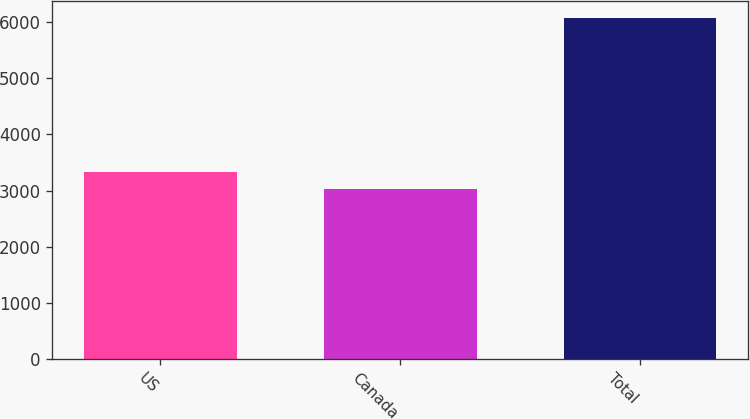Convert chart. <chart><loc_0><loc_0><loc_500><loc_500><bar_chart><fcel>US<fcel>Canada<fcel>Total<nl><fcel>3337.6<fcel>3033<fcel>6079<nl></chart> 